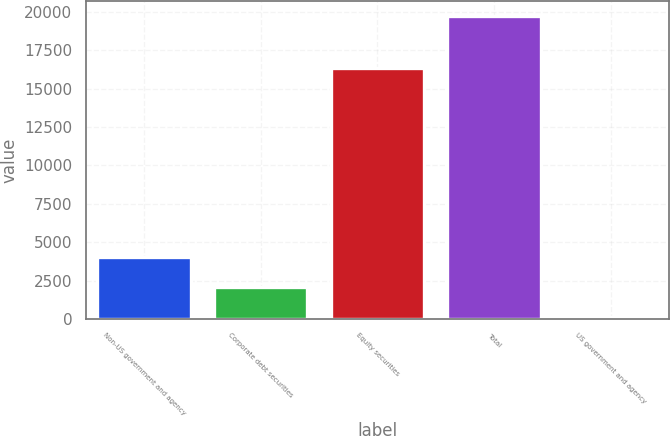<chart> <loc_0><loc_0><loc_500><loc_500><bar_chart><fcel>Non-US government and agency<fcel>Corporate debt securities<fcel>Equity securities<fcel>Total<fcel>US government and agency<nl><fcel>4037.6<fcel>2076.3<fcel>16338<fcel>19728<fcel>115<nl></chart> 